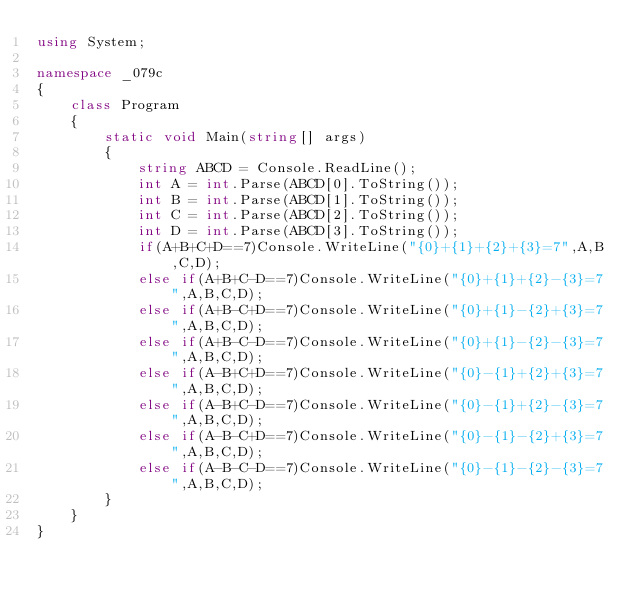Convert code to text. <code><loc_0><loc_0><loc_500><loc_500><_C#_>using System;

namespace _079c
{
    class Program
    {
        static void Main(string[] args)
        {
            string ABCD = Console.ReadLine();
            int A = int.Parse(ABCD[0].ToString());
            int B = int.Parse(ABCD[1].ToString());
            int C = int.Parse(ABCD[2].ToString());
            int D = int.Parse(ABCD[3].ToString());
            if(A+B+C+D==7)Console.WriteLine("{0}+{1}+{2}+{3}=7",A,B,C,D);
            else if(A+B+C-D==7)Console.WriteLine("{0}+{1}+{2}-{3}=7",A,B,C,D);
            else if(A+B-C+D==7)Console.WriteLine("{0}+{1}-{2}+{3}=7",A,B,C,D);
            else if(A+B-C-D==7)Console.WriteLine("{0}+{1}-{2}-{3}=7",A,B,C,D);
            else if(A-B+C+D==7)Console.WriteLine("{0}-{1}+{2}+{3}=7",A,B,C,D);
            else if(A-B+C-D==7)Console.WriteLine("{0}-{1}+{2}-{3}=7",A,B,C,D);
            else if(A-B-C+D==7)Console.WriteLine("{0}-{1}-{2}+{3}=7",A,B,C,D);
            else if(A-B-C-D==7)Console.WriteLine("{0}-{1}-{2}-{3}=7",A,B,C,D);
        }
    }
}
</code> 